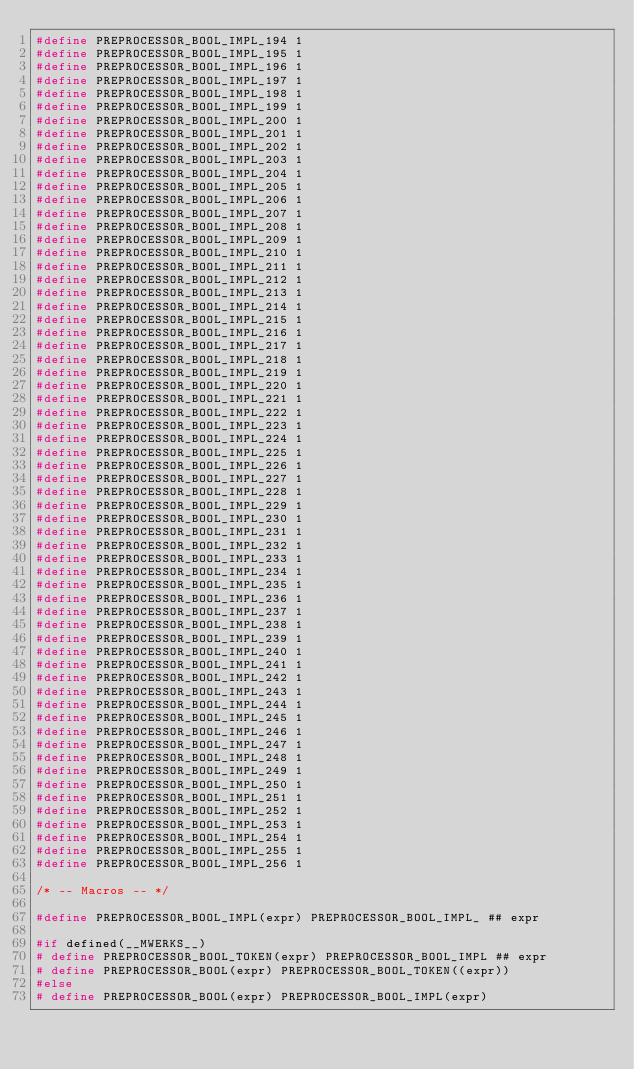<code> <loc_0><loc_0><loc_500><loc_500><_C_>#define PREPROCESSOR_BOOL_IMPL_194 1
#define PREPROCESSOR_BOOL_IMPL_195 1
#define PREPROCESSOR_BOOL_IMPL_196 1
#define PREPROCESSOR_BOOL_IMPL_197 1
#define PREPROCESSOR_BOOL_IMPL_198 1
#define PREPROCESSOR_BOOL_IMPL_199 1
#define PREPROCESSOR_BOOL_IMPL_200 1
#define PREPROCESSOR_BOOL_IMPL_201 1
#define PREPROCESSOR_BOOL_IMPL_202 1
#define PREPROCESSOR_BOOL_IMPL_203 1
#define PREPROCESSOR_BOOL_IMPL_204 1
#define PREPROCESSOR_BOOL_IMPL_205 1
#define PREPROCESSOR_BOOL_IMPL_206 1
#define PREPROCESSOR_BOOL_IMPL_207 1
#define PREPROCESSOR_BOOL_IMPL_208 1
#define PREPROCESSOR_BOOL_IMPL_209 1
#define PREPROCESSOR_BOOL_IMPL_210 1
#define PREPROCESSOR_BOOL_IMPL_211 1
#define PREPROCESSOR_BOOL_IMPL_212 1
#define PREPROCESSOR_BOOL_IMPL_213 1
#define PREPROCESSOR_BOOL_IMPL_214 1
#define PREPROCESSOR_BOOL_IMPL_215 1
#define PREPROCESSOR_BOOL_IMPL_216 1
#define PREPROCESSOR_BOOL_IMPL_217 1
#define PREPROCESSOR_BOOL_IMPL_218 1
#define PREPROCESSOR_BOOL_IMPL_219 1
#define PREPROCESSOR_BOOL_IMPL_220 1
#define PREPROCESSOR_BOOL_IMPL_221 1
#define PREPROCESSOR_BOOL_IMPL_222 1
#define PREPROCESSOR_BOOL_IMPL_223 1
#define PREPROCESSOR_BOOL_IMPL_224 1
#define PREPROCESSOR_BOOL_IMPL_225 1
#define PREPROCESSOR_BOOL_IMPL_226 1
#define PREPROCESSOR_BOOL_IMPL_227 1
#define PREPROCESSOR_BOOL_IMPL_228 1
#define PREPROCESSOR_BOOL_IMPL_229 1
#define PREPROCESSOR_BOOL_IMPL_230 1
#define PREPROCESSOR_BOOL_IMPL_231 1
#define PREPROCESSOR_BOOL_IMPL_232 1
#define PREPROCESSOR_BOOL_IMPL_233 1
#define PREPROCESSOR_BOOL_IMPL_234 1
#define PREPROCESSOR_BOOL_IMPL_235 1
#define PREPROCESSOR_BOOL_IMPL_236 1
#define PREPROCESSOR_BOOL_IMPL_237 1
#define PREPROCESSOR_BOOL_IMPL_238 1
#define PREPROCESSOR_BOOL_IMPL_239 1
#define PREPROCESSOR_BOOL_IMPL_240 1
#define PREPROCESSOR_BOOL_IMPL_241 1
#define PREPROCESSOR_BOOL_IMPL_242 1
#define PREPROCESSOR_BOOL_IMPL_243 1
#define PREPROCESSOR_BOOL_IMPL_244 1
#define PREPROCESSOR_BOOL_IMPL_245 1
#define PREPROCESSOR_BOOL_IMPL_246 1
#define PREPROCESSOR_BOOL_IMPL_247 1
#define PREPROCESSOR_BOOL_IMPL_248 1
#define PREPROCESSOR_BOOL_IMPL_249 1
#define PREPROCESSOR_BOOL_IMPL_250 1
#define PREPROCESSOR_BOOL_IMPL_251 1
#define PREPROCESSOR_BOOL_IMPL_252 1
#define PREPROCESSOR_BOOL_IMPL_253 1
#define PREPROCESSOR_BOOL_IMPL_254 1
#define PREPROCESSOR_BOOL_IMPL_255 1
#define PREPROCESSOR_BOOL_IMPL_256 1

/* -- Macros -- */

#define PREPROCESSOR_BOOL_IMPL(expr) PREPROCESSOR_BOOL_IMPL_ ## expr

#if defined(__MWERKS__)
#	define PREPROCESSOR_BOOL_TOKEN(expr) PREPROCESSOR_BOOL_IMPL ## expr
#	define PREPROCESSOR_BOOL(expr) PREPROCESSOR_BOOL_TOKEN((expr))
#else
#	define PREPROCESSOR_BOOL(expr) PREPROCESSOR_BOOL_IMPL(expr)</code> 